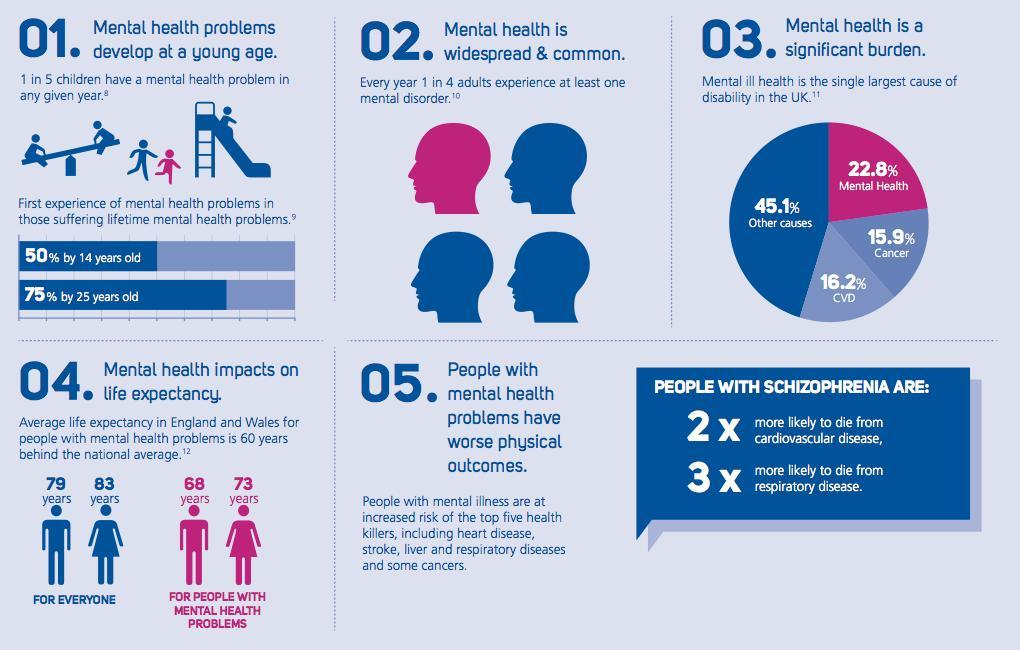What number of adults are not prone to at least one mental health disorder?
Answer the question with a short phrase. 3 in 4 Who has more life expectancy among those with mental health problems- men or women? women What percent of teenagers experience mental health problems by the time they are in their teens? 50% In UK which is the leading cause of disability after mental health? CVD What is the life expectancy of a woman with mental health problems in England and Wales? 73 years 